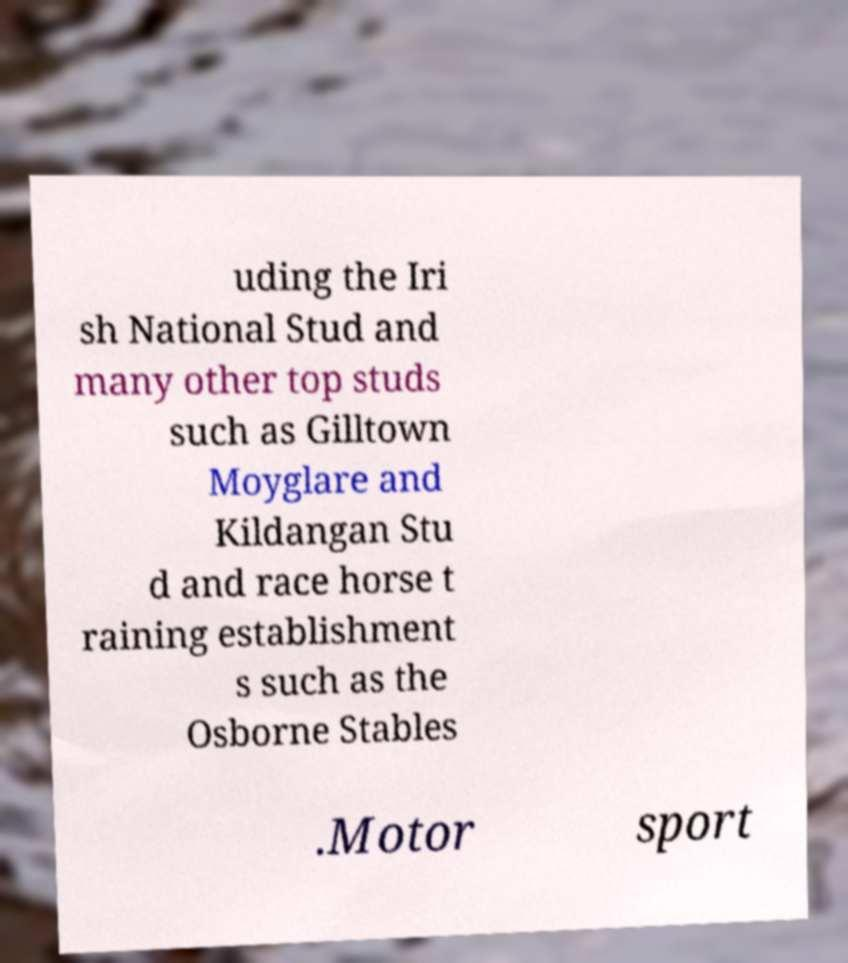Please read and relay the text visible in this image. What does it say? uding the Iri sh National Stud and many other top studs such as Gilltown Moyglare and Kildangan Stu d and race horse t raining establishment s such as the Osborne Stables .Motor sport 